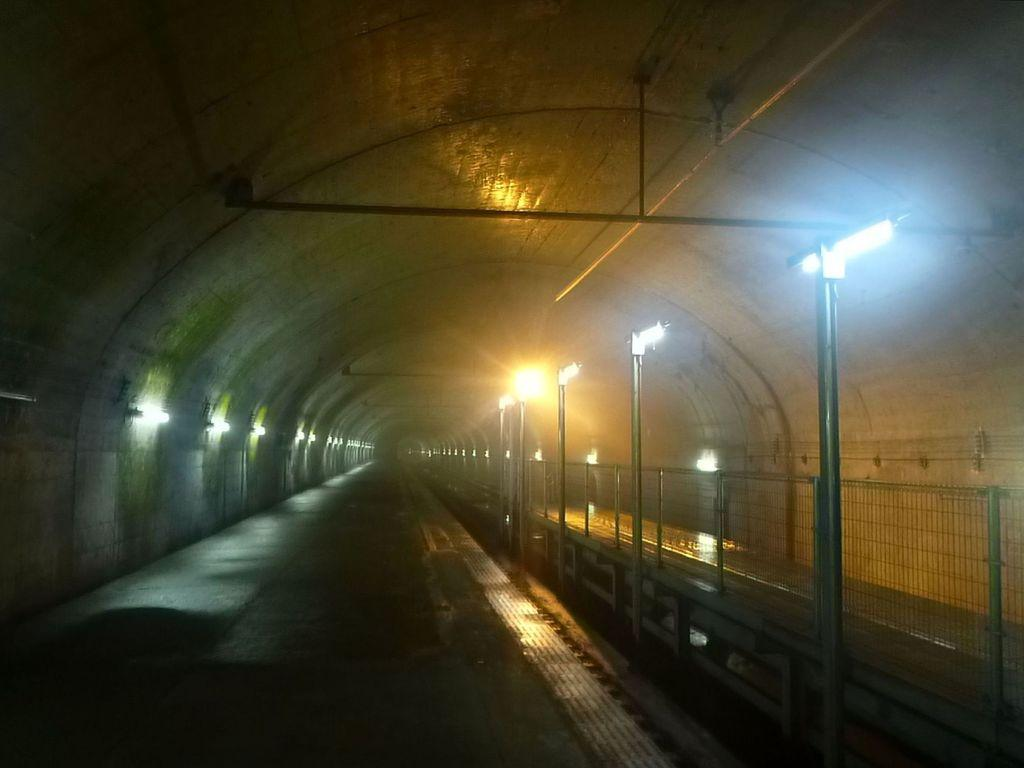What is the main feature of the image? There is a tunnel in the image. What can be seen inside the tunnel? There are light poles, fencing, and lights inside the tunnel. Can you see a tramp or a frog inside the tunnel? No, there is no tramp or frog visible in the image. The image only shows a tunnel with light poles, fencing, and lights. 